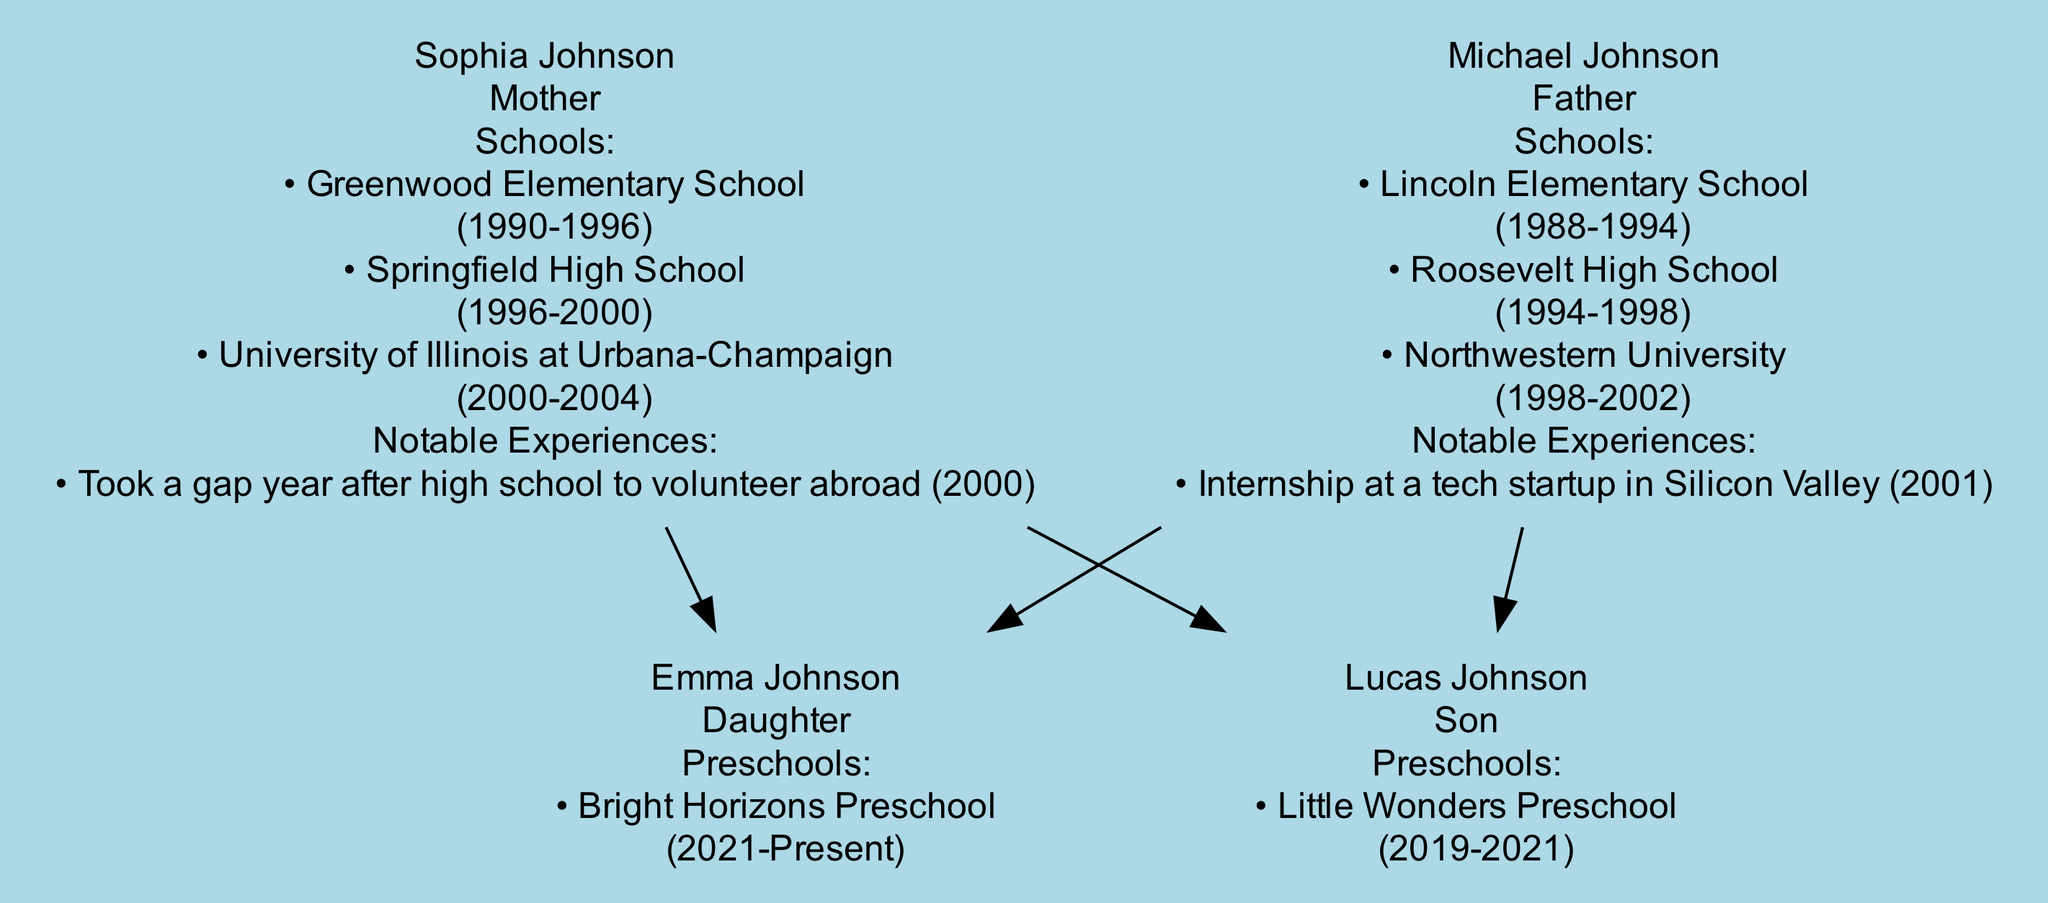What is the highest educational degree attained by Sophia Johnson? According to the diagram, Sophia Johnson has a Bachelor of Arts degree in Psychology from the University of Illinois at Urbana-Champaign, which is the highest educational degree listed for her.
Answer: B.A. in Psychology Which school did Michael Johnson attend right after elementary school? The diagram shows that Michael Johnson attended Roosevelt High School immediately after finishing Lincoln Elementary School, based on the sequential list of schools in his educational background.
Answer: Roosevelt High School How many preschools did Lucas Johnson attend? The diagram indicates that Lucas Johnson attended one preschool, which is identified in the educational background section. Counting the listed preschools shows that there is only one.
Answer: One What notable experience did Sophia Johnson have in 2000? The diagram describes that Sophia Johnson took a gap year after high school to volunteer abroad in 2000, which indicates a significant event during that year.
Answer: Volunteer abroad How many family members have attended Northwestern University? From the information in the diagram, it shows that only one family member, Michael Johnson, attended Northwestern University, indicating that he is the sole representative for that institution.
Answer: One What is the relationship between Emma Johnson and Sophia Johnson? The diagram clearly specifies that Emma Johnson is a daughter of Sophia Johnson, highlighting the direct familial relationship between them.
Answer: Daughter What year did Lucas Johnson attend Little Wonders Preschool? The diagram provides that Lucas Johnson attended Little Wonders Preschool from 2019 to 2021, which indicates both the starting and ending years of his preschool education.
Answer: 2019-2021 Which educational institution did Michael Johnson attend for his undergraduate studies? The diagram specifically lists Northwestern University as the institution where Michael Johnson completed his undergraduate studies, making it a clear answer.
Answer: Northwestern University Did Sophia Johnson have any gaps in her educational journey? The diagram indicates a notable experience where Sophia took a gap year to volunteer abroad after her high school, which qualifies as a significant gap in her educational pathway.
Answer: Yes 